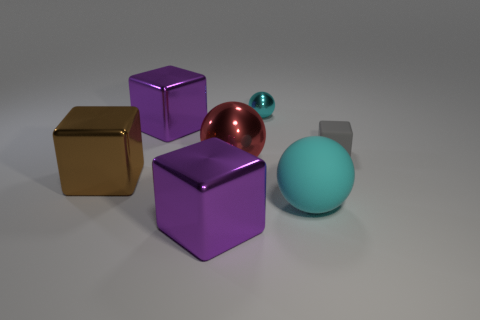Add 1 gray cylinders. How many objects exist? 8 Subtract all big metallic blocks. How many blocks are left? 1 Subtract all spheres. How many objects are left? 4 Subtract all gray cylinders. How many yellow balls are left? 0 Subtract all cyan shiny spheres. Subtract all cyan shiny spheres. How many objects are left? 5 Add 1 gray blocks. How many gray blocks are left? 2 Add 2 large balls. How many large balls exist? 4 Subtract all red balls. How many balls are left? 2 Subtract 0 yellow spheres. How many objects are left? 7 Subtract 3 cubes. How many cubes are left? 1 